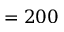<formula> <loc_0><loc_0><loc_500><loc_500>= 2 0 0</formula> 